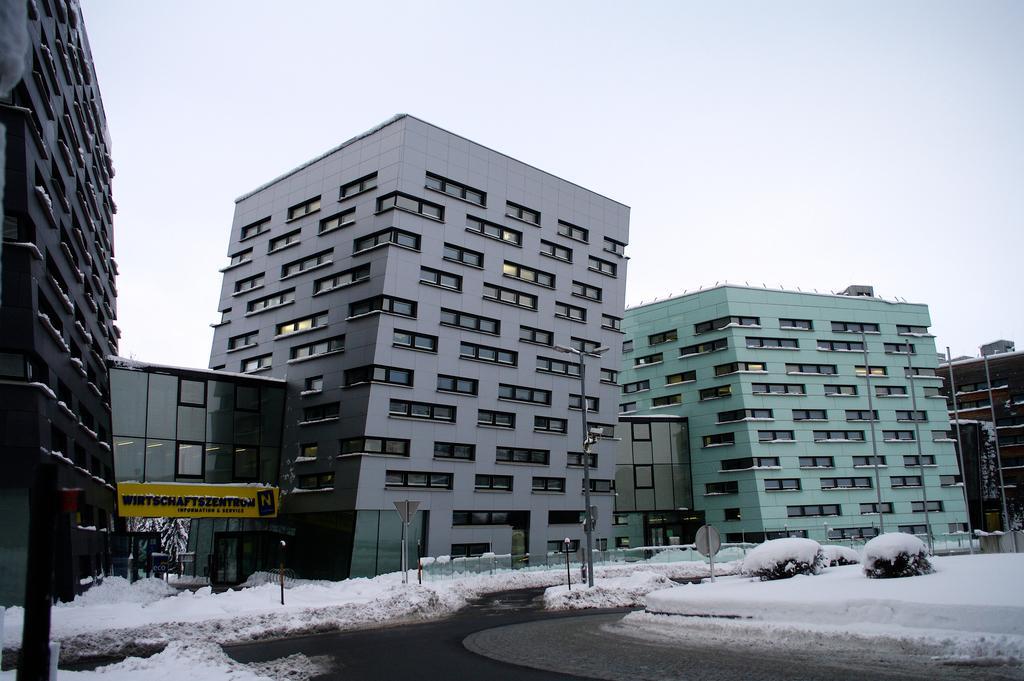Describe this image in one or two sentences. In this image there is the sky truncated towards the top of the image, there are buildings, there is a building truncated towards the right of the image, there is a building truncated towards the left of the image, there are boards, there is text on the board, there are poles, there are trees, there is ice, there is ice truncated towards the right of the image, there is road truncated towards the bottom of the image, there is ice truncated towards the bottom of the image, there is ice truncated towards the left of the image. 